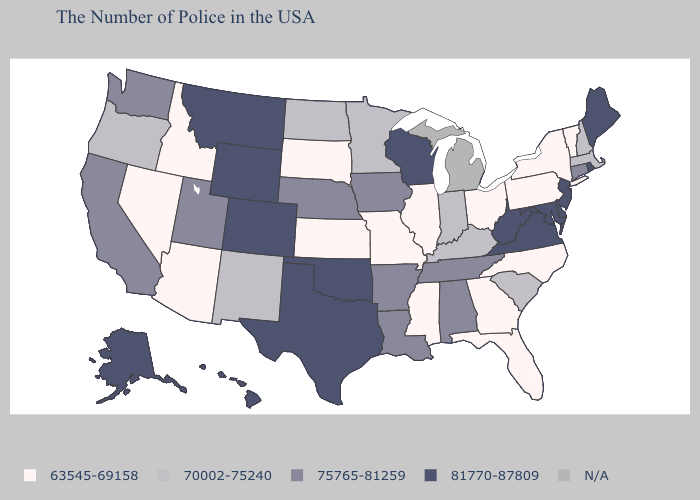Among the states that border Illinois , does Missouri have the lowest value?
Answer briefly. Yes. Does Missouri have the lowest value in the USA?
Concise answer only. Yes. Which states have the lowest value in the West?
Short answer required. Arizona, Idaho, Nevada. Does Alaska have the highest value in the USA?
Give a very brief answer. Yes. Among the states that border Maryland , which have the highest value?
Quick response, please. Delaware, Virginia, West Virginia. Among the states that border Iowa , does Illinois have the lowest value?
Short answer required. Yes. Which states have the lowest value in the Northeast?
Short answer required. Vermont, New York, Pennsylvania. Name the states that have a value in the range N/A?
Answer briefly. Michigan. What is the value of Missouri?
Quick response, please. 63545-69158. Which states have the highest value in the USA?
Short answer required. Maine, Rhode Island, New Jersey, Delaware, Maryland, Virginia, West Virginia, Wisconsin, Oklahoma, Texas, Wyoming, Colorado, Montana, Alaska, Hawaii. Which states have the highest value in the USA?
Keep it brief. Maine, Rhode Island, New Jersey, Delaware, Maryland, Virginia, West Virginia, Wisconsin, Oklahoma, Texas, Wyoming, Colorado, Montana, Alaska, Hawaii. What is the lowest value in states that border West Virginia?
Give a very brief answer. 63545-69158. Name the states that have a value in the range 81770-87809?
Concise answer only. Maine, Rhode Island, New Jersey, Delaware, Maryland, Virginia, West Virginia, Wisconsin, Oklahoma, Texas, Wyoming, Colorado, Montana, Alaska, Hawaii. 